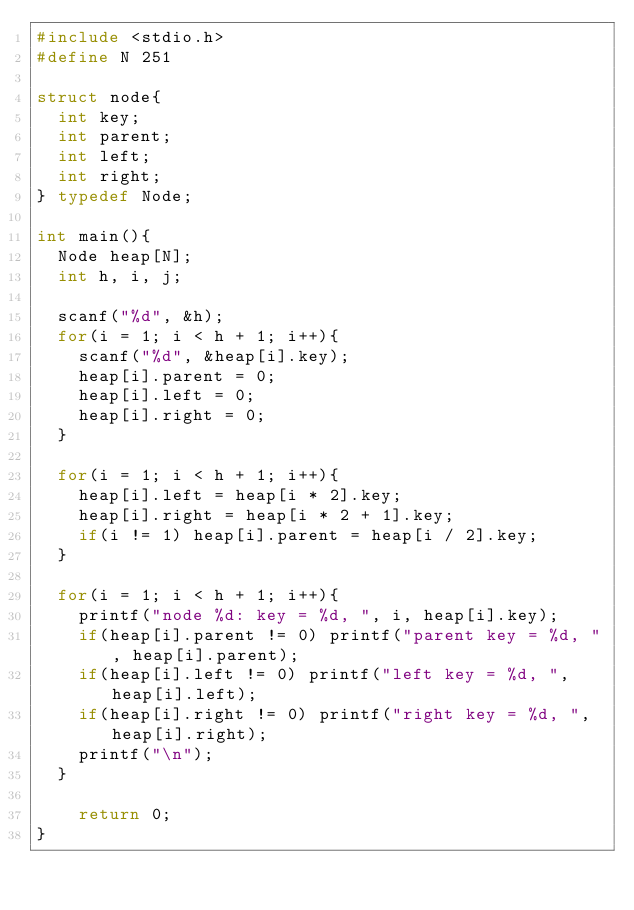Convert code to text. <code><loc_0><loc_0><loc_500><loc_500><_C_>#include <stdio.h>
#define N 251

struct node{
  int key;
  int parent;
  int left;
  int right;
} typedef Node;

int main(){
  Node heap[N];
  int h, i, j;

  scanf("%d", &h);
  for(i = 1; i < h + 1; i++){
    scanf("%d", &heap[i].key);
    heap[i].parent = 0;
    heap[i].left = 0;
    heap[i].right = 0;
  }

  for(i = 1; i < h + 1; i++){
    heap[i].left = heap[i * 2].key;
    heap[i].right = heap[i * 2 + 1].key;
    if(i != 1) heap[i].parent = heap[i / 2].key;
  }

  for(i = 1; i < h + 1; i++){
    printf("node %d: key = %d, ", i, heap[i].key);
    if(heap[i].parent != 0) printf("parent key = %d, ", heap[i].parent);
    if(heap[i].left != 0) printf("left key = %d, ", heap[i].left);
    if(heap[i].right != 0) printf("right key = %d, ", heap[i].right);
    printf("\n");
  }

    return 0;
}</code> 